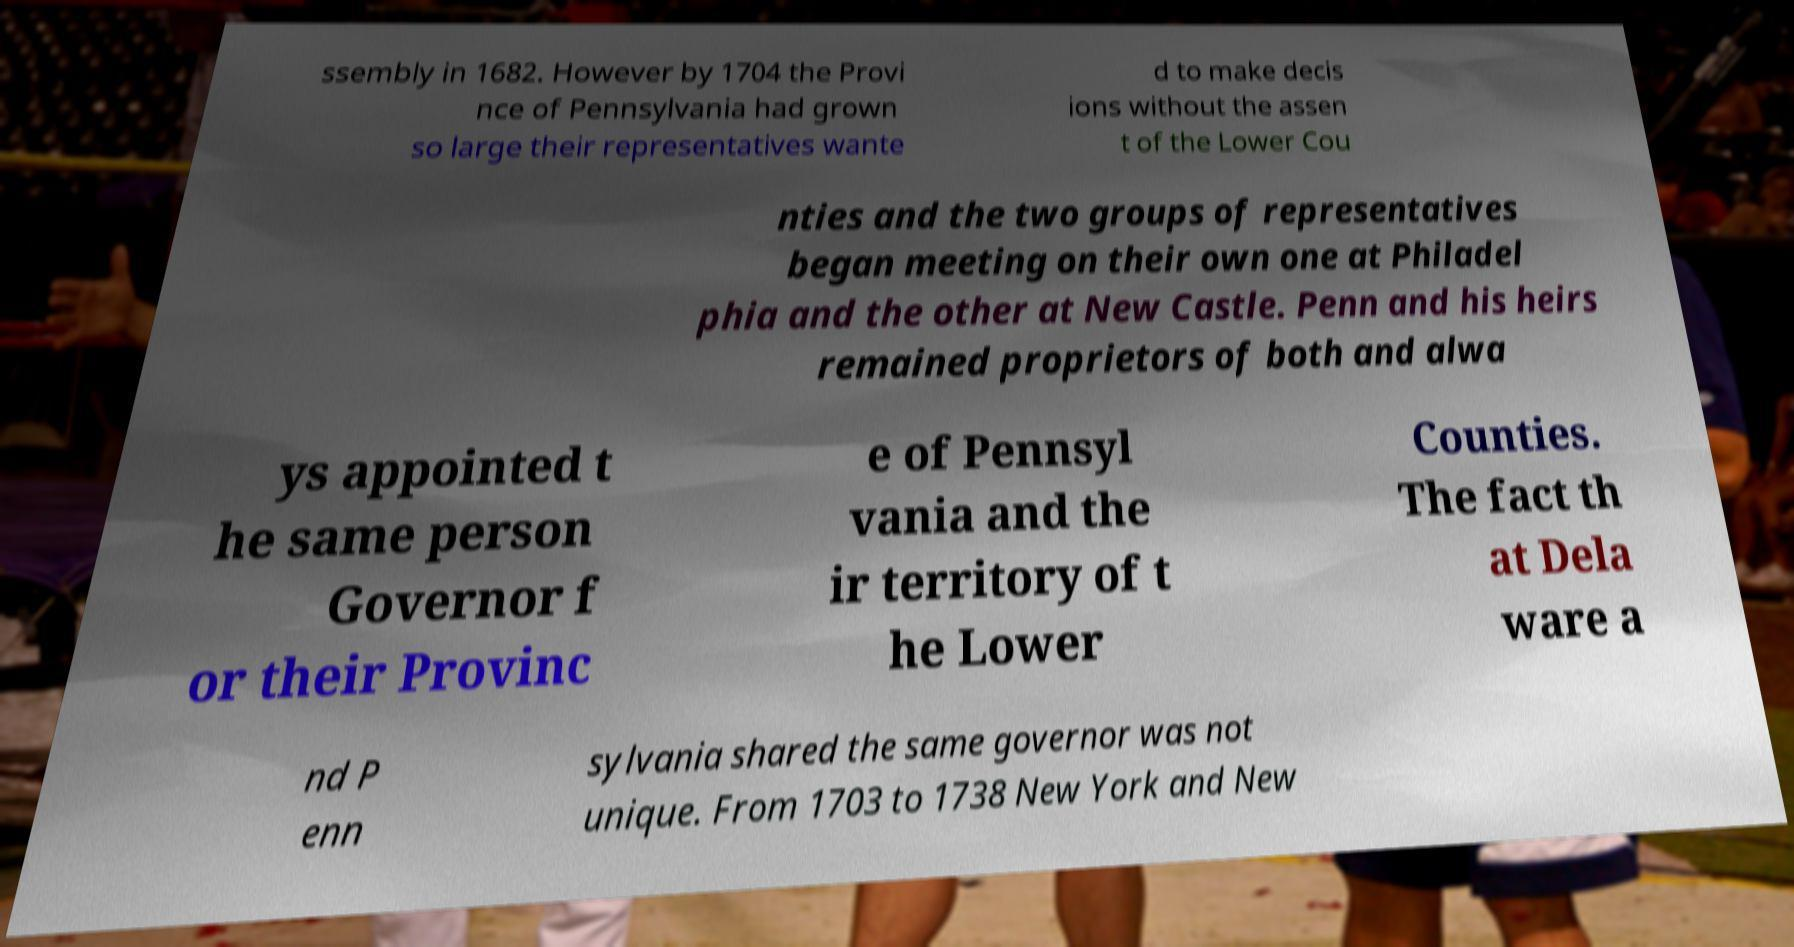For documentation purposes, I need the text within this image transcribed. Could you provide that? ssembly in 1682. However by 1704 the Provi nce of Pennsylvania had grown so large their representatives wante d to make decis ions without the assen t of the Lower Cou nties and the two groups of representatives began meeting on their own one at Philadel phia and the other at New Castle. Penn and his heirs remained proprietors of both and alwa ys appointed t he same person Governor f or their Provinc e of Pennsyl vania and the ir territory of t he Lower Counties. The fact th at Dela ware a nd P enn sylvania shared the same governor was not unique. From 1703 to 1738 New York and New 